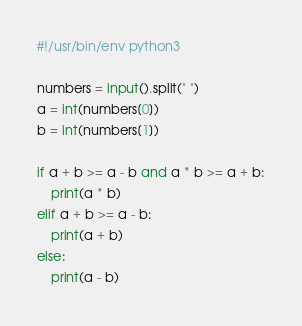<code> <loc_0><loc_0><loc_500><loc_500><_Python_>#!/usr/bin/env python3

numbers = input().split(" ")
a = int(numbers[0])
b = int(numbers[1])

if a + b >= a - b and a * b >= a + b:
    print(a * b)
elif a + b >= a - b:
    print(a + b)
else:
    print(a - b)</code> 